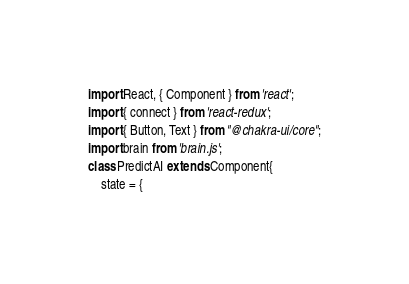<code> <loc_0><loc_0><loc_500><loc_500><_JavaScript_>import React, { Component } from 'react';
import { connect } from 'react-redux';
import { Button, Text } from "@chakra-ui/core";
import brain from 'brain.js';
class PredictAI extends Component{
    state = {</code> 